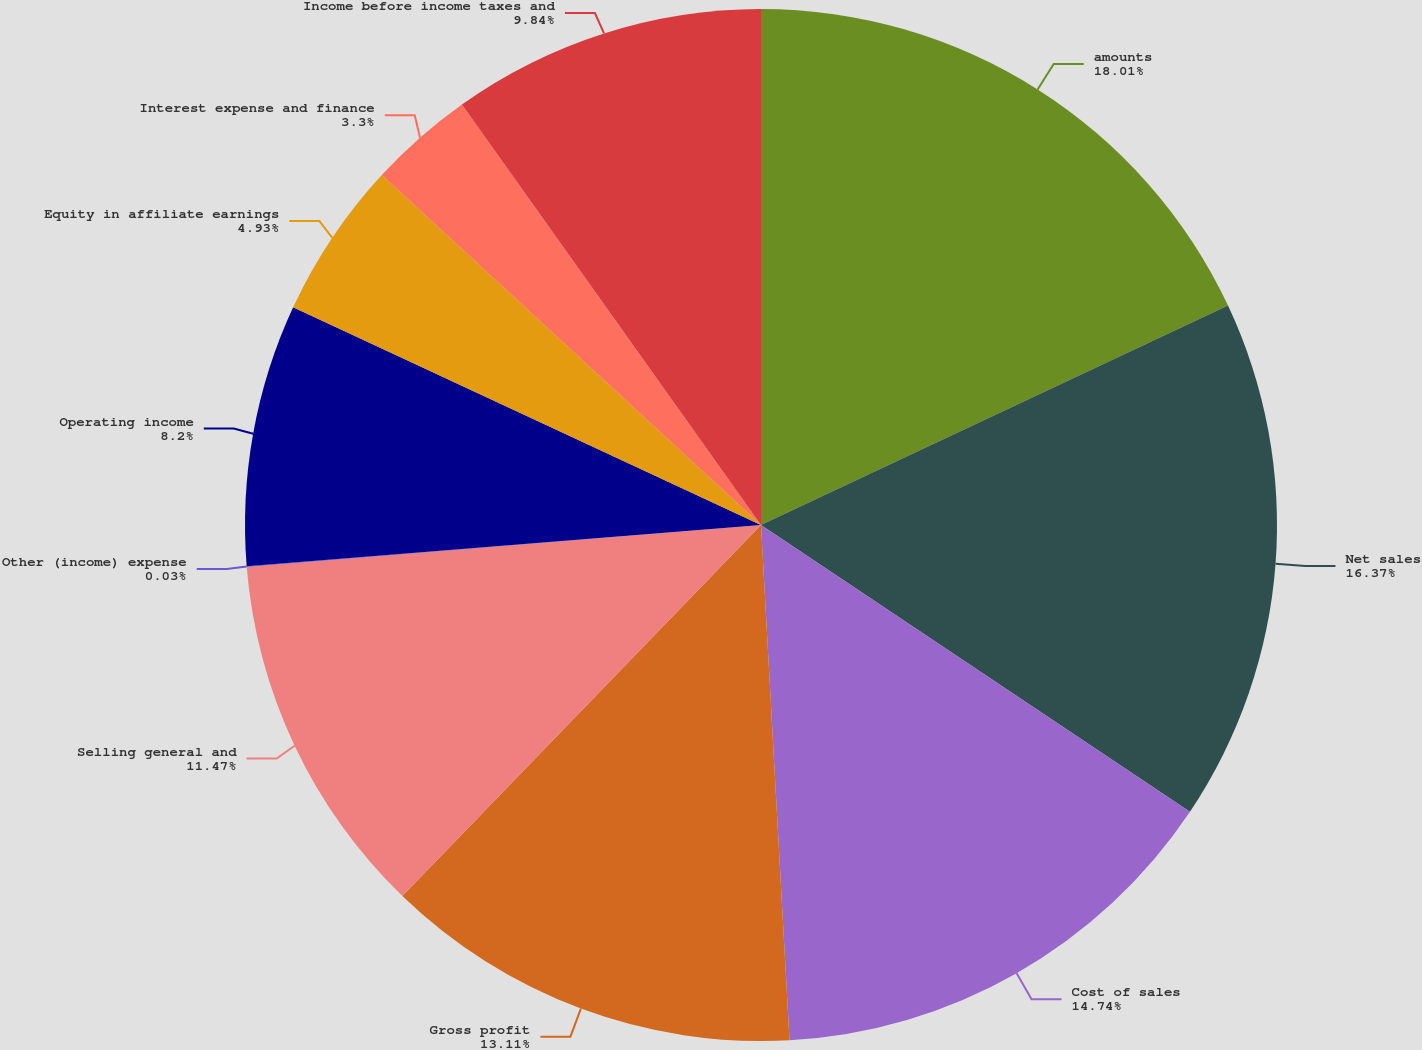Convert chart. <chart><loc_0><loc_0><loc_500><loc_500><pie_chart><fcel>amounts<fcel>Net sales<fcel>Cost of sales<fcel>Gross profit<fcel>Selling general and<fcel>Other (income) expense<fcel>Operating income<fcel>Equity in affiliate earnings<fcel>Interest expense and finance<fcel>Income before income taxes and<nl><fcel>18.01%<fcel>16.37%<fcel>14.74%<fcel>13.11%<fcel>11.47%<fcel>0.03%<fcel>8.2%<fcel>4.93%<fcel>3.3%<fcel>9.84%<nl></chart> 